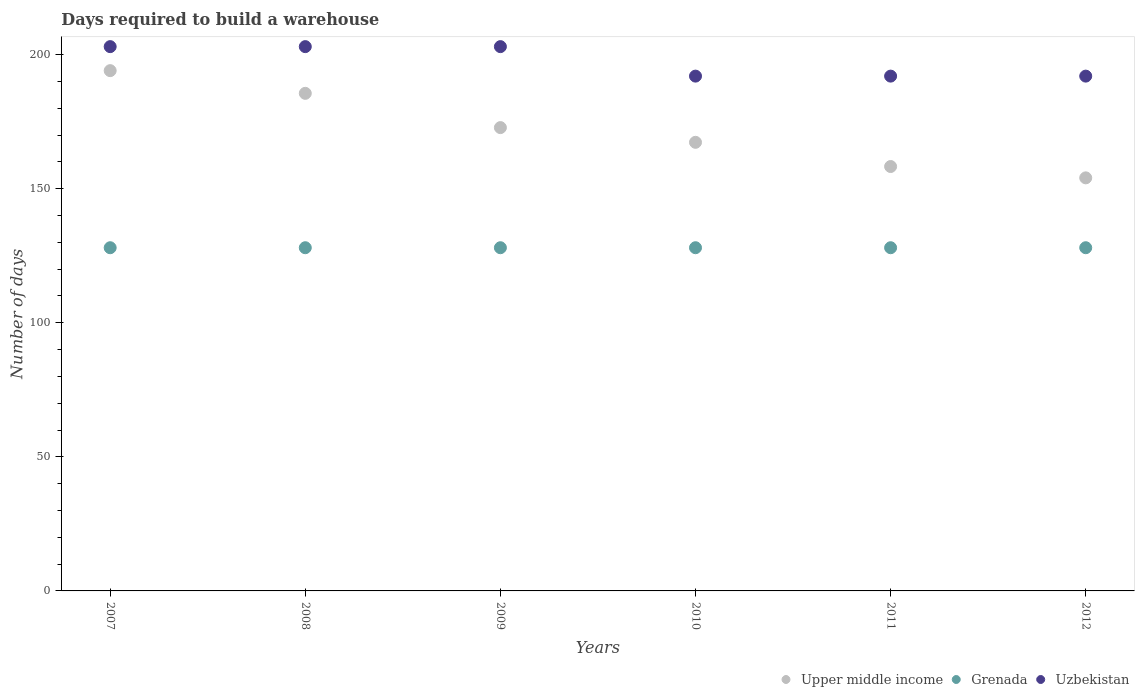Is the number of dotlines equal to the number of legend labels?
Your answer should be compact. Yes. What is the days required to build a warehouse in in Upper middle income in 2007?
Your answer should be very brief. 194.04. Across all years, what is the maximum days required to build a warehouse in in Grenada?
Ensure brevity in your answer.  128. Across all years, what is the minimum days required to build a warehouse in in Uzbekistan?
Make the answer very short. 192. What is the total days required to build a warehouse in in Upper middle income in the graph?
Keep it short and to the point. 1032.07. What is the difference between the days required to build a warehouse in in Grenada in 2009 and that in 2012?
Keep it short and to the point. 0. What is the difference between the days required to build a warehouse in in Uzbekistan in 2009 and the days required to build a warehouse in in Upper middle income in 2008?
Your answer should be very brief. 17.42. What is the average days required to build a warehouse in in Upper middle income per year?
Make the answer very short. 172.01. In the year 2008, what is the difference between the days required to build a warehouse in in Upper middle income and days required to build a warehouse in in Uzbekistan?
Provide a succinct answer. -17.42. In how many years, is the days required to build a warehouse in in Grenada greater than 120 days?
Your answer should be very brief. 6. What is the ratio of the days required to build a warehouse in in Upper middle income in 2009 to that in 2010?
Your answer should be very brief. 1.03. Is the days required to build a warehouse in in Upper middle income in 2009 less than that in 2012?
Give a very brief answer. No. Is the difference between the days required to build a warehouse in in Upper middle income in 2011 and 2012 greater than the difference between the days required to build a warehouse in in Uzbekistan in 2011 and 2012?
Offer a very short reply. Yes. What is the difference between the highest and the second highest days required to build a warehouse in in Upper middle income?
Offer a terse response. 8.47. What is the difference between the highest and the lowest days required to build a warehouse in in Upper middle income?
Your answer should be very brief. 39.99. In how many years, is the days required to build a warehouse in in Upper middle income greater than the average days required to build a warehouse in in Upper middle income taken over all years?
Provide a short and direct response. 3. Is it the case that in every year, the sum of the days required to build a warehouse in in Grenada and days required to build a warehouse in in Uzbekistan  is greater than the days required to build a warehouse in in Upper middle income?
Your answer should be very brief. Yes. Is the days required to build a warehouse in in Upper middle income strictly greater than the days required to build a warehouse in in Grenada over the years?
Provide a succinct answer. Yes. Is the days required to build a warehouse in in Uzbekistan strictly less than the days required to build a warehouse in in Grenada over the years?
Offer a terse response. No. How many dotlines are there?
Your answer should be compact. 3. What is the difference between two consecutive major ticks on the Y-axis?
Ensure brevity in your answer.  50. Does the graph contain grids?
Give a very brief answer. No. How are the legend labels stacked?
Provide a succinct answer. Horizontal. What is the title of the graph?
Your answer should be compact. Days required to build a warehouse. What is the label or title of the Y-axis?
Provide a succinct answer. Number of days. What is the Number of days in Upper middle income in 2007?
Your answer should be compact. 194.04. What is the Number of days in Grenada in 2007?
Your answer should be compact. 128. What is the Number of days of Uzbekistan in 2007?
Ensure brevity in your answer.  203. What is the Number of days in Upper middle income in 2008?
Give a very brief answer. 185.58. What is the Number of days of Grenada in 2008?
Provide a short and direct response. 128. What is the Number of days in Uzbekistan in 2008?
Make the answer very short. 203. What is the Number of days in Upper middle income in 2009?
Keep it short and to the point. 172.8. What is the Number of days of Grenada in 2009?
Make the answer very short. 128. What is the Number of days in Uzbekistan in 2009?
Make the answer very short. 203. What is the Number of days in Upper middle income in 2010?
Keep it short and to the point. 167.31. What is the Number of days in Grenada in 2010?
Your response must be concise. 128. What is the Number of days in Uzbekistan in 2010?
Provide a succinct answer. 192. What is the Number of days in Upper middle income in 2011?
Keep it short and to the point. 158.28. What is the Number of days of Grenada in 2011?
Keep it short and to the point. 128. What is the Number of days in Uzbekistan in 2011?
Keep it short and to the point. 192. What is the Number of days of Upper middle income in 2012?
Provide a short and direct response. 154.06. What is the Number of days of Grenada in 2012?
Provide a succinct answer. 128. What is the Number of days of Uzbekistan in 2012?
Give a very brief answer. 192. Across all years, what is the maximum Number of days of Upper middle income?
Your answer should be compact. 194.04. Across all years, what is the maximum Number of days of Grenada?
Keep it short and to the point. 128. Across all years, what is the maximum Number of days of Uzbekistan?
Ensure brevity in your answer.  203. Across all years, what is the minimum Number of days in Upper middle income?
Provide a short and direct response. 154.06. Across all years, what is the minimum Number of days of Grenada?
Your answer should be very brief. 128. Across all years, what is the minimum Number of days in Uzbekistan?
Provide a short and direct response. 192. What is the total Number of days of Upper middle income in the graph?
Your answer should be very brief. 1032.07. What is the total Number of days of Grenada in the graph?
Give a very brief answer. 768. What is the total Number of days of Uzbekistan in the graph?
Ensure brevity in your answer.  1185. What is the difference between the Number of days of Upper middle income in 2007 and that in 2008?
Give a very brief answer. 8.47. What is the difference between the Number of days in Grenada in 2007 and that in 2008?
Offer a terse response. 0. What is the difference between the Number of days in Uzbekistan in 2007 and that in 2008?
Make the answer very short. 0. What is the difference between the Number of days of Upper middle income in 2007 and that in 2009?
Ensure brevity in your answer.  21.24. What is the difference between the Number of days of Grenada in 2007 and that in 2009?
Your answer should be compact. 0. What is the difference between the Number of days in Uzbekistan in 2007 and that in 2009?
Your response must be concise. 0. What is the difference between the Number of days of Upper middle income in 2007 and that in 2010?
Give a very brief answer. 26.73. What is the difference between the Number of days in Upper middle income in 2007 and that in 2011?
Your response must be concise. 35.76. What is the difference between the Number of days of Grenada in 2007 and that in 2011?
Make the answer very short. 0. What is the difference between the Number of days of Uzbekistan in 2007 and that in 2011?
Your answer should be compact. 11. What is the difference between the Number of days of Upper middle income in 2007 and that in 2012?
Your answer should be compact. 39.99. What is the difference between the Number of days of Grenada in 2007 and that in 2012?
Provide a succinct answer. 0. What is the difference between the Number of days of Uzbekistan in 2007 and that in 2012?
Make the answer very short. 11. What is the difference between the Number of days of Upper middle income in 2008 and that in 2009?
Your answer should be compact. 12.78. What is the difference between the Number of days in Grenada in 2008 and that in 2009?
Give a very brief answer. 0. What is the difference between the Number of days of Upper middle income in 2008 and that in 2010?
Ensure brevity in your answer.  18.27. What is the difference between the Number of days in Grenada in 2008 and that in 2010?
Make the answer very short. 0. What is the difference between the Number of days in Uzbekistan in 2008 and that in 2010?
Provide a succinct answer. 11. What is the difference between the Number of days of Upper middle income in 2008 and that in 2011?
Provide a short and direct response. 27.29. What is the difference between the Number of days in Uzbekistan in 2008 and that in 2011?
Keep it short and to the point. 11. What is the difference between the Number of days in Upper middle income in 2008 and that in 2012?
Your answer should be very brief. 31.52. What is the difference between the Number of days of Grenada in 2008 and that in 2012?
Your response must be concise. 0. What is the difference between the Number of days in Uzbekistan in 2008 and that in 2012?
Offer a terse response. 11. What is the difference between the Number of days in Upper middle income in 2009 and that in 2010?
Provide a succinct answer. 5.49. What is the difference between the Number of days of Uzbekistan in 2009 and that in 2010?
Your answer should be very brief. 11. What is the difference between the Number of days of Upper middle income in 2009 and that in 2011?
Offer a terse response. 14.52. What is the difference between the Number of days of Grenada in 2009 and that in 2011?
Your answer should be compact. 0. What is the difference between the Number of days in Uzbekistan in 2009 and that in 2011?
Offer a terse response. 11. What is the difference between the Number of days in Upper middle income in 2009 and that in 2012?
Give a very brief answer. 18.74. What is the difference between the Number of days in Upper middle income in 2010 and that in 2011?
Keep it short and to the point. 9.03. What is the difference between the Number of days in Upper middle income in 2010 and that in 2012?
Make the answer very short. 13.25. What is the difference between the Number of days in Upper middle income in 2011 and that in 2012?
Your answer should be compact. 4.23. What is the difference between the Number of days in Uzbekistan in 2011 and that in 2012?
Offer a terse response. 0. What is the difference between the Number of days of Upper middle income in 2007 and the Number of days of Grenada in 2008?
Your answer should be very brief. 66.04. What is the difference between the Number of days in Upper middle income in 2007 and the Number of days in Uzbekistan in 2008?
Give a very brief answer. -8.96. What is the difference between the Number of days in Grenada in 2007 and the Number of days in Uzbekistan in 2008?
Keep it short and to the point. -75. What is the difference between the Number of days of Upper middle income in 2007 and the Number of days of Grenada in 2009?
Make the answer very short. 66.04. What is the difference between the Number of days in Upper middle income in 2007 and the Number of days in Uzbekistan in 2009?
Give a very brief answer. -8.96. What is the difference between the Number of days in Grenada in 2007 and the Number of days in Uzbekistan in 2009?
Keep it short and to the point. -75. What is the difference between the Number of days of Upper middle income in 2007 and the Number of days of Grenada in 2010?
Provide a short and direct response. 66.04. What is the difference between the Number of days of Upper middle income in 2007 and the Number of days of Uzbekistan in 2010?
Your response must be concise. 2.04. What is the difference between the Number of days in Grenada in 2007 and the Number of days in Uzbekistan in 2010?
Provide a short and direct response. -64. What is the difference between the Number of days of Upper middle income in 2007 and the Number of days of Grenada in 2011?
Your answer should be very brief. 66.04. What is the difference between the Number of days in Upper middle income in 2007 and the Number of days in Uzbekistan in 2011?
Offer a terse response. 2.04. What is the difference between the Number of days of Grenada in 2007 and the Number of days of Uzbekistan in 2011?
Offer a very short reply. -64. What is the difference between the Number of days of Upper middle income in 2007 and the Number of days of Grenada in 2012?
Offer a terse response. 66.04. What is the difference between the Number of days of Upper middle income in 2007 and the Number of days of Uzbekistan in 2012?
Your response must be concise. 2.04. What is the difference between the Number of days in Grenada in 2007 and the Number of days in Uzbekistan in 2012?
Provide a succinct answer. -64. What is the difference between the Number of days in Upper middle income in 2008 and the Number of days in Grenada in 2009?
Your response must be concise. 57.58. What is the difference between the Number of days in Upper middle income in 2008 and the Number of days in Uzbekistan in 2009?
Your response must be concise. -17.42. What is the difference between the Number of days in Grenada in 2008 and the Number of days in Uzbekistan in 2009?
Your answer should be very brief. -75. What is the difference between the Number of days in Upper middle income in 2008 and the Number of days in Grenada in 2010?
Your response must be concise. 57.58. What is the difference between the Number of days of Upper middle income in 2008 and the Number of days of Uzbekistan in 2010?
Keep it short and to the point. -6.42. What is the difference between the Number of days in Grenada in 2008 and the Number of days in Uzbekistan in 2010?
Ensure brevity in your answer.  -64. What is the difference between the Number of days in Upper middle income in 2008 and the Number of days in Grenada in 2011?
Give a very brief answer. 57.58. What is the difference between the Number of days of Upper middle income in 2008 and the Number of days of Uzbekistan in 2011?
Ensure brevity in your answer.  -6.42. What is the difference between the Number of days of Grenada in 2008 and the Number of days of Uzbekistan in 2011?
Keep it short and to the point. -64. What is the difference between the Number of days of Upper middle income in 2008 and the Number of days of Grenada in 2012?
Your answer should be compact. 57.58. What is the difference between the Number of days in Upper middle income in 2008 and the Number of days in Uzbekistan in 2012?
Make the answer very short. -6.42. What is the difference between the Number of days of Grenada in 2008 and the Number of days of Uzbekistan in 2012?
Your answer should be compact. -64. What is the difference between the Number of days of Upper middle income in 2009 and the Number of days of Grenada in 2010?
Give a very brief answer. 44.8. What is the difference between the Number of days of Upper middle income in 2009 and the Number of days of Uzbekistan in 2010?
Ensure brevity in your answer.  -19.2. What is the difference between the Number of days of Grenada in 2009 and the Number of days of Uzbekistan in 2010?
Offer a very short reply. -64. What is the difference between the Number of days of Upper middle income in 2009 and the Number of days of Grenada in 2011?
Give a very brief answer. 44.8. What is the difference between the Number of days of Upper middle income in 2009 and the Number of days of Uzbekistan in 2011?
Your answer should be very brief. -19.2. What is the difference between the Number of days of Grenada in 2009 and the Number of days of Uzbekistan in 2011?
Your response must be concise. -64. What is the difference between the Number of days of Upper middle income in 2009 and the Number of days of Grenada in 2012?
Offer a very short reply. 44.8. What is the difference between the Number of days of Upper middle income in 2009 and the Number of days of Uzbekistan in 2012?
Provide a succinct answer. -19.2. What is the difference between the Number of days in Grenada in 2009 and the Number of days in Uzbekistan in 2012?
Provide a short and direct response. -64. What is the difference between the Number of days of Upper middle income in 2010 and the Number of days of Grenada in 2011?
Offer a very short reply. 39.31. What is the difference between the Number of days of Upper middle income in 2010 and the Number of days of Uzbekistan in 2011?
Your answer should be compact. -24.69. What is the difference between the Number of days of Grenada in 2010 and the Number of days of Uzbekistan in 2011?
Your answer should be very brief. -64. What is the difference between the Number of days in Upper middle income in 2010 and the Number of days in Grenada in 2012?
Ensure brevity in your answer.  39.31. What is the difference between the Number of days in Upper middle income in 2010 and the Number of days in Uzbekistan in 2012?
Provide a succinct answer. -24.69. What is the difference between the Number of days of Grenada in 2010 and the Number of days of Uzbekistan in 2012?
Your response must be concise. -64. What is the difference between the Number of days of Upper middle income in 2011 and the Number of days of Grenada in 2012?
Your answer should be compact. 30.28. What is the difference between the Number of days of Upper middle income in 2011 and the Number of days of Uzbekistan in 2012?
Give a very brief answer. -33.72. What is the difference between the Number of days in Grenada in 2011 and the Number of days in Uzbekistan in 2012?
Ensure brevity in your answer.  -64. What is the average Number of days in Upper middle income per year?
Give a very brief answer. 172.01. What is the average Number of days in Grenada per year?
Offer a very short reply. 128. What is the average Number of days in Uzbekistan per year?
Your answer should be compact. 197.5. In the year 2007, what is the difference between the Number of days of Upper middle income and Number of days of Grenada?
Provide a short and direct response. 66.04. In the year 2007, what is the difference between the Number of days in Upper middle income and Number of days in Uzbekistan?
Give a very brief answer. -8.96. In the year 2007, what is the difference between the Number of days of Grenada and Number of days of Uzbekistan?
Provide a succinct answer. -75. In the year 2008, what is the difference between the Number of days of Upper middle income and Number of days of Grenada?
Ensure brevity in your answer.  57.58. In the year 2008, what is the difference between the Number of days in Upper middle income and Number of days in Uzbekistan?
Ensure brevity in your answer.  -17.42. In the year 2008, what is the difference between the Number of days of Grenada and Number of days of Uzbekistan?
Keep it short and to the point. -75. In the year 2009, what is the difference between the Number of days in Upper middle income and Number of days in Grenada?
Provide a short and direct response. 44.8. In the year 2009, what is the difference between the Number of days of Upper middle income and Number of days of Uzbekistan?
Offer a terse response. -30.2. In the year 2009, what is the difference between the Number of days in Grenada and Number of days in Uzbekistan?
Keep it short and to the point. -75. In the year 2010, what is the difference between the Number of days of Upper middle income and Number of days of Grenada?
Make the answer very short. 39.31. In the year 2010, what is the difference between the Number of days in Upper middle income and Number of days in Uzbekistan?
Offer a terse response. -24.69. In the year 2010, what is the difference between the Number of days of Grenada and Number of days of Uzbekistan?
Your answer should be compact. -64. In the year 2011, what is the difference between the Number of days in Upper middle income and Number of days in Grenada?
Keep it short and to the point. 30.28. In the year 2011, what is the difference between the Number of days of Upper middle income and Number of days of Uzbekistan?
Provide a short and direct response. -33.72. In the year 2011, what is the difference between the Number of days in Grenada and Number of days in Uzbekistan?
Keep it short and to the point. -64. In the year 2012, what is the difference between the Number of days of Upper middle income and Number of days of Grenada?
Make the answer very short. 26.06. In the year 2012, what is the difference between the Number of days of Upper middle income and Number of days of Uzbekistan?
Provide a succinct answer. -37.94. In the year 2012, what is the difference between the Number of days in Grenada and Number of days in Uzbekistan?
Provide a succinct answer. -64. What is the ratio of the Number of days in Upper middle income in 2007 to that in 2008?
Make the answer very short. 1.05. What is the ratio of the Number of days in Upper middle income in 2007 to that in 2009?
Provide a short and direct response. 1.12. What is the ratio of the Number of days of Grenada in 2007 to that in 2009?
Offer a very short reply. 1. What is the ratio of the Number of days of Upper middle income in 2007 to that in 2010?
Your answer should be very brief. 1.16. What is the ratio of the Number of days in Uzbekistan in 2007 to that in 2010?
Your response must be concise. 1.06. What is the ratio of the Number of days in Upper middle income in 2007 to that in 2011?
Keep it short and to the point. 1.23. What is the ratio of the Number of days of Uzbekistan in 2007 to that in 2011?
Provide a succinct answer. 1.06. What is the ratio of the Number of days of Upper middle income in 2007 to that in 2012?
Offer a terse response. 1.26. What is the ratio of the Number of days of Grenada in 2007 to that in 2012?
Provide a succinct answer. 1. What is the ratio of the Number of days of Uzbekistan in 2007 to that in 2012?
Your response must be concise. 1.06. What is the ratio of the Number of days in Upper middle income in 2008 to that in 2009?
Offer a very short reply. 1.07. What is the ratio of the Number of days of Grenada in 2008 to that in 2009?
Keep it short and to the point. 1. What is the ratio of the Number of days in Upper middle income in 2008 to that in 2010?
Ensure brevity in your answer.  1.11. What is the ratio of the Number of days of Uzbekistan in 2008 to that in 2010?
Provide a short and direct response. 1.06. What is the ratio of the Number of days of Upper middle income in 2008 to that in 2011?
Make the answer very short. 1.17. What is the ratio of the Number of days in Grenada in 2008 to that in 2011?
Offer a very short reply. 1. What is the ratio of the Number of days in Uzbekistan in 2008 to that in 2011?
Offer a terse response. 1.06. What is the ratio of the Number of days in Upper middle income in 2008 to that in 2012?
Keep it short and to the point. 1.2. What is the ratio of the Number of days in Grenada in 2008 to that in 2012?
Your answer should be compact. 1. What is the ratio of the Number of days of Uzbekistan in 2008 to that in 2012?
Provide a short and direct response. 1.06. What is the ratio of the Number of days of Upper middle income in 2009 to that in 2010?
Provide a short and direct response. 1.03. What is the ratio of the Number of days of Grenada in 2009 to that in 2010?
Your answer should be very brief. 1. What is the ratio of the Number of days in Uzbekistan in 2009 to that in 2010?
Provide a succinct answer. 1.06. What is the ratio of the Number of days of Upper middle income in 2009 to that in 2011?
Offer a very short reply. 1.09. What is the ratio of the Number of days of Uzbekistan in 2009 to that in 2011?
Provide a short and direct response. 1.06. What is the ratio of the Number of days of Upper middle income in 2009 to that in 2012?
Ensure brevity in your answer.  1.12. What is the ratio of the Number of days of Grenada in 2009 to that in 2012?
Make the answer very short. 1. What is the ratio of the Number of days in Uzbekistan in 2009 to that in 2012?
Your answer should be very brief. 1.06. What is the ratio of the Number of days in Upper middle income in 2010 to that in 2011?
Offer a terse response. 1.06. What is the ratio of the Number of days in Upper middle income in 2010 to that in 2012?
Offer a terse response. 1.09. What is the ratio of the Number of days of Uzbekistan in 2010 to that in 2012?
Make the answer very short. 1. What is the ratio of the Number of days of Upper middle income in 2011 to that in 2012?
Provide a succinct answer. 1.03. What is the difference between the highest and the second highest Number of days in Upper middle income?
Provide a short and direct response. 8.47. What is the difference between the highest and the second highest Number of days in Grenada?
Provide a short and direct response. 0. What is the difference between the highest and the second highest Number of days of Uzbekistan?
Your answer should be very brief. 0. What is the difference between the highest and the lowest Number of days of Upper middle income?
Your answer should be compact. 39.99. What is the difference between the highest and the lowest Number of days of Grenada?
Your answer should be very brief. 0. 